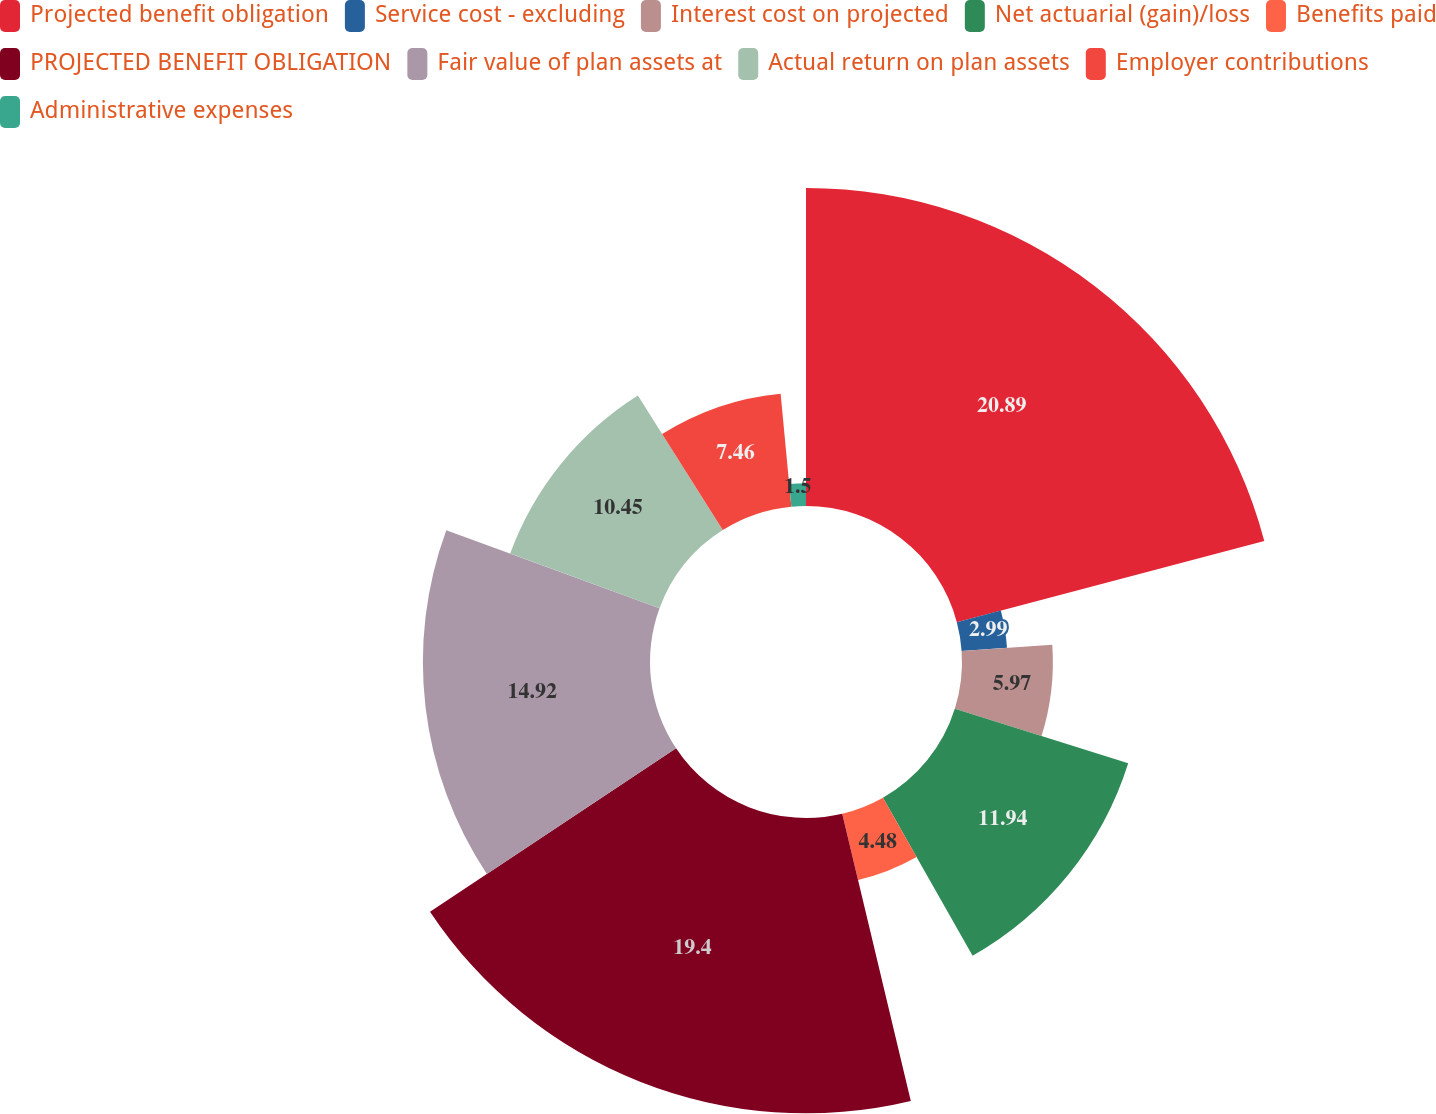Convert chart to OTSL. <chart><loc_0><loc_0><loc_500><loc_500><pie_chart><fcel>Projected benefit obligation<fcel>Service cost - excluding<fcel>Interest cost on projected<fcel>Net actuarial (gain)/loss<fcel>Benefits paid<fcel>PROJECTED BENEFIT OBLIGATION<fcel>Fair value of plan assets at<fcel>Actual return on plan assets<fcel>Employer contributions<fcel>Administrative expenses<nl><fcel>20.89%<fcel>2.99%<fcel>5.97%<fcel>11.94%<fcel>4.48%<fcel>19.4%<fcel>14.92%<fcel>10.45%<fcel>7.46%<fcel>1.5%<nl></chart> 